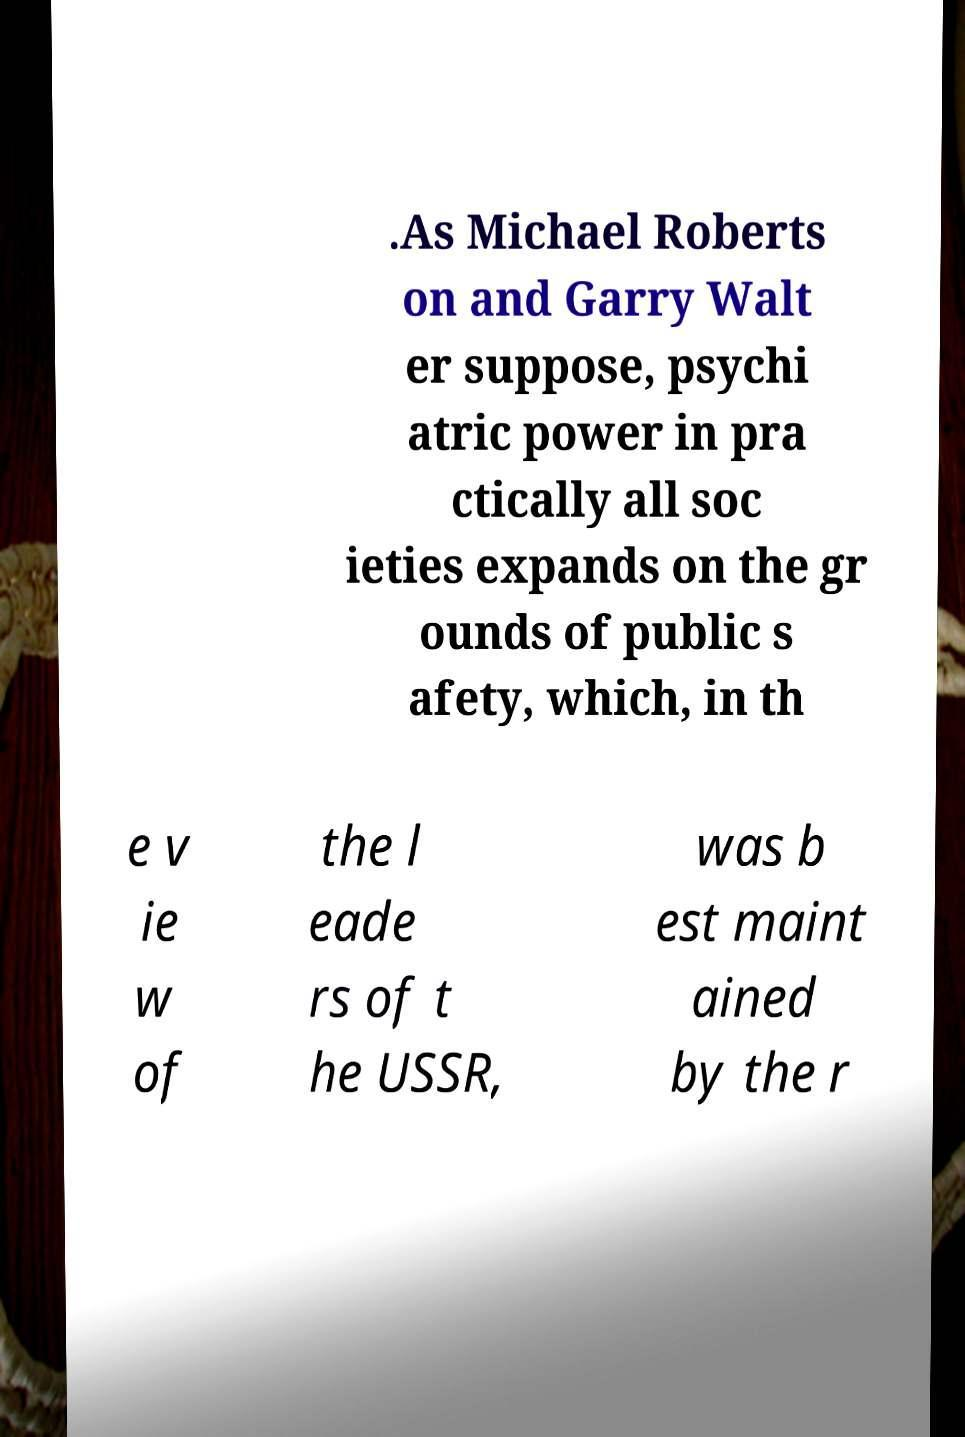I need the written content from this picture converted into text. Can you do that? .As Michael Roberts on and Garry Walt er suppose, psychi atric power in pra ctically all soc ieties expands on the gr ounds of public s afety, which, in th e v ie w of the l eade rs of t he USSR, was b est maint ained by the r 